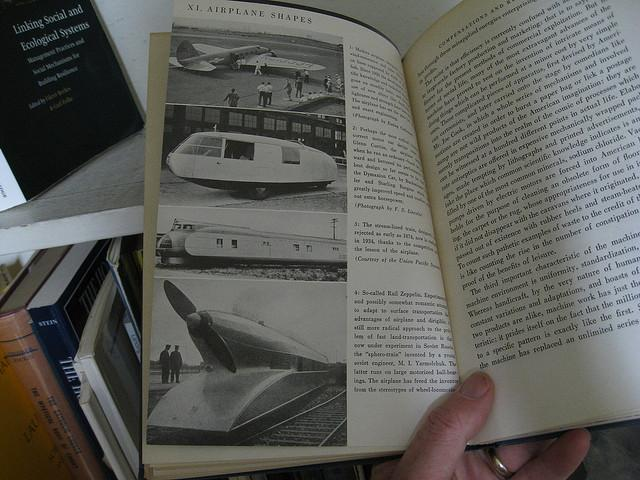What kind of object is to the front of this strange train? propeller 